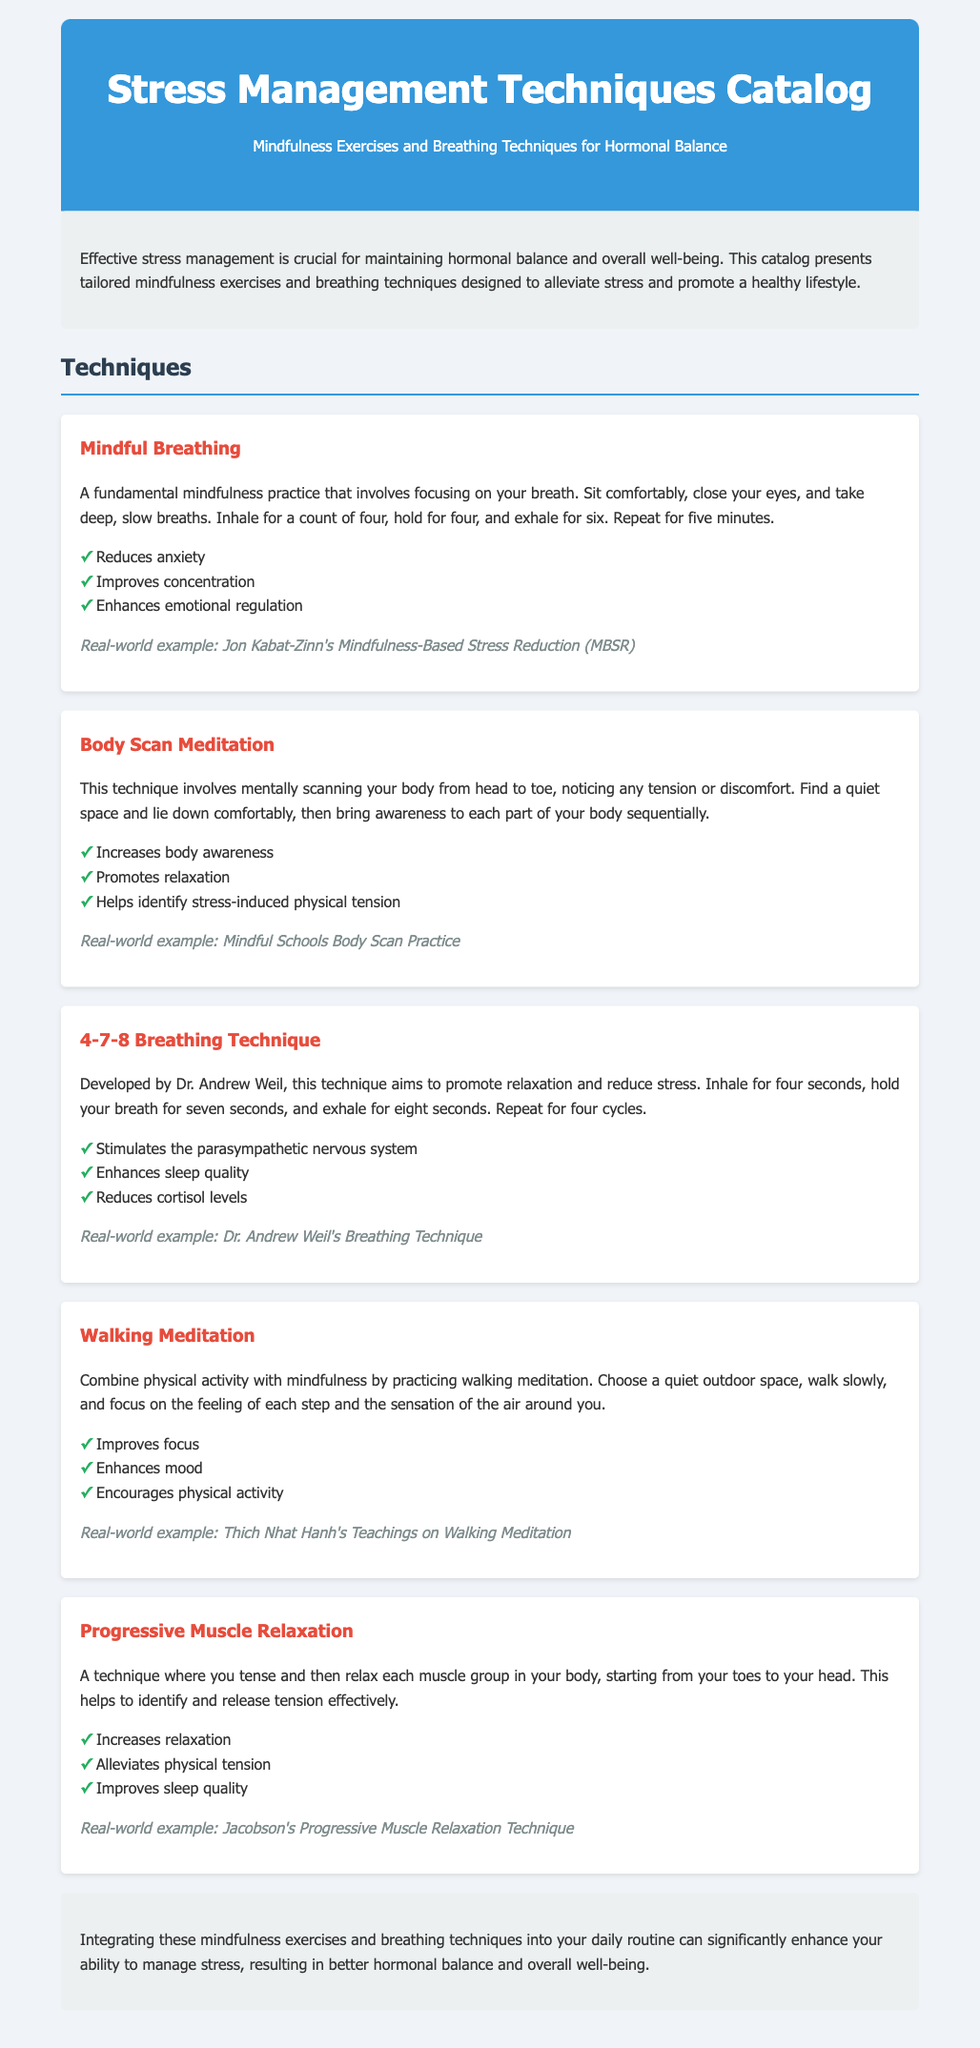What is the title of the catalog? The title of the catalog is provided at the beginning of the document, highlighting the subject matter.
Answer: Stress Management Techniques Catalog What is the purpose of the catalog? The purpose outlines the significance of stress management related to hormonal balance and well-being in the introductory section.
Answer: To alleviate stress and promote a healthy lifestyle How many mindfulness techniques are listed? The document lists the techniques under the "Techniques" section, making it easy to count them.
Answer: Five What is the main benefit of Mindful Breathing? The benefits of each technique are listed under them, with Mindful Breathing highlighted specifically.
Answer: Reduces anxiety Who developed the 4-7-8 Breathing Technique? The document attributes this technique to a specific individual in the explanation section.
Answer: Dr. Andrew Weil What does the Body Scan Meditation help identify? This is described in the benefits section under Body Scan Meditation.
Answer: Stress-induced physical tension What is the real-world example for Walking Meditation? The real-world examples provide practical application insights for each technique.
Answer: Thich Nhat Hanh's Teachings on Walking Meditation What is one benefit of Progressive Muscle Relaxation? The document lists benefits under each technique, emphasizing key outcomes.
Answer: Improves sleep quality 